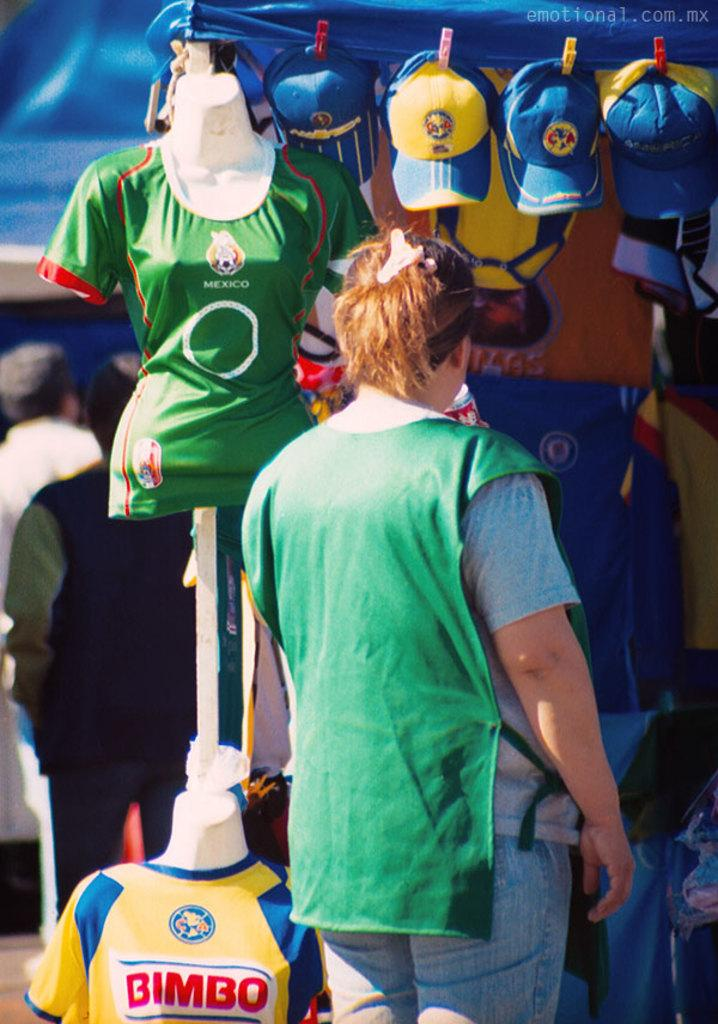<image>
Give a short and clear explanation of the subsequent image. a woman wearing a green smock looking at hats and a yellow jersey labeled bimbo 